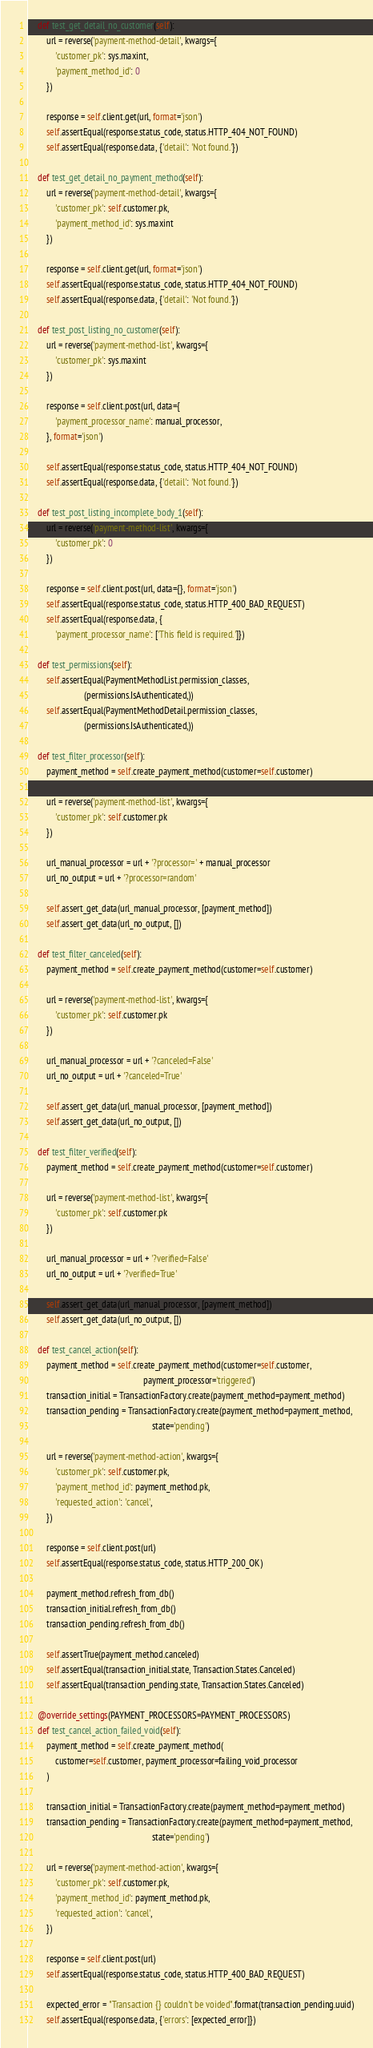<code> <loc_0><loc_0><loc_500><loc_500><_Python_>
    def test_get_detail_no_customer(self):
        url = reverse('payment-method-detail', kwargs={
            'customer_pk': sys.maxint,
            'payment_method_id': 0
        })

        response = self.client.get(url, format='json')
        self.assertEqual(response.status_code, status.HTTP_404_NOT_FOUND)
        self.assertEqual(response.data, {'detail': 'Not found.'})

    def test_get_detail_no_payment_method(self):
        url = reverse('payment-method-detail', kwargs={
            'customer_pk': self.customer.pk,
            'payment_method_id': sys.maxint
        })

        response = self.client.get(url, format='json')
        self.assertEqual(response.status_code, status.HTTP_404_NOT_FOUND)
        self.assertEqual(response.data, {'detail': 'Not found.'})

    def test_post_listing_no_customer(self):
        url = reverse('payment-method-list', kwargs={
            'customer_pk': sys.maxint
        })

        response = self.client.post(url, data={
            'payment_processor_name': manual_processor,
        }, format='json')

        self.assertEqual(response.status_code, status.HTTP_404_NOT_FOUND)
        self.assertEqual(response.data, {'detail': 'Not found.'})

    def test_post_listing_incomplete_body_1(self):
        url = reverse('payment-method-list', kwargs={
            'customer_pk': 0
        })

        response = self.client.post(url, data={}, format='json')
        self.assertEqual(response.status_code, status.HTTP_400_BAD_REQUEST)
        self.assertEqual(response.data, {
            'payment_processor_name': ['This field is required.']})

    def test_permissions(self):
        self.assertEqual(PaymentMethodList.permission_classes,
                         (permissions.IsAuthenticated,))
        self.assertEqual(PaymentMethodDetail.permission_classes,
                         (permissions.IsAuthenticated,))

    def test_filter_processor(self):
        payment_method = self.create_payment_method(customer=self.customer)

        url = reverse('payment-method-list', kwargs={
            'customer_pk': self.customer.pk
        })

        url_manual_processor = url + '?processor=' + manual_processor
        url_no_output = url + '?processor=random'

        self.assert_get_data(url_manual_processor, [payment_method])
        self.assert_get_data(url_no_output, [])

    def test_filter_canceled(self):
        payment_method = self.create_payment_method(customer=self.customer)

        url = reverse('payment-method-list', kwargs={
            'customer_pk': self.customer.pk
        })

        url_manual_processor = url + '?canceled=False'
        url_no_output = url + '?canceled=True'

        self.assert_get_data(url_manual_processor, [payment_method])
        self.assert_get_data(url_no_output, [])

    def test_filter_verified(self):
        payment_method = self.create_payment_method(customer=self.customer)

        url = reverse('payment-method-list', kwargs={
            'customer_pk': self.customer.pk
        })

        url_manual_processor = url + '?verified=False'
        url_no_output = url + '?verified=True'

        self.assert_get_data(url_manual_processor, [payment_method])
        self.assert_get_data(url_no_output, [])

    def test_cancel_action(self):
        payment_method = self.create_payment_method(customer=self.customer,
                                                    payment_processor='triggered')
        transaction_initial = TransactionFactory.create(payment_method=payment_method)
        transaction_pending = TransactionFactory.create(payment_method=payment_method,
                                                        state='pending')

        url = reverse('payment-method-action', kwargs={
            'customer_pk': self.customer.pk,
            'payment_method_id': payment_method.pk,
            'requested_action': 'cancel',
        })

        response = self.client.post(url)
        self.assertEqual(response.status_code, status.HTTP_200_OK)

        payment_method.refresh_from_db()
        transaction_initial.refresh_from_db()
        transaction_pending.refresh_from_db()

        self.assertTrue(payment_method.canceled)
        self.assertEqual(transaction_initial.state, Transaction.States.Canceled)
        self.assertEqual(transaction_pending.state, Transaction.States.Canceled)

    @override_settings(PAYMENT_PROCESSORS=PAYMENT_PROCESSORS)
    def test_cancel_action_failed_void(self):
        payment_method = self.create_payment_method(
            customer=self.customer, payment_processor=failing_void_processor
        )

        transaction_initial = TransactionFactory.create(payment_method=payment_method)
        transaction_pending = TransactionFactory.create(payment_method=payment_method,
                                                        state='pending')

        url = reverse('payment-method-action', kwargs={
            'customer_pk': self.customer.pk,
            'payment_method_id': payment_method.pk,
            'requested_action': 'cancel',
        })

        response = self.client.post(url)
        self.assertEqual(response.status_code, status.HTTP_400_BAD_REQUEST)

        expected_error = "Transaction {} couldn't be voided".format(transaction_pending.uuid)
        self.assertEqual(response.data, {'errors': [expected_error]})
</code> 